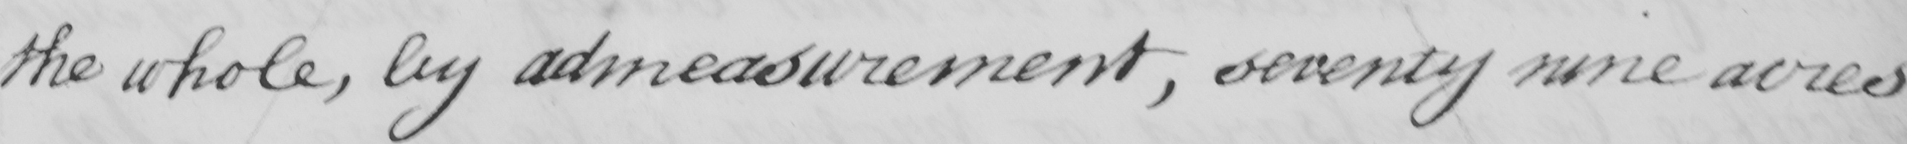Transcribe the text shown in this historical manuscript line. the whole , by admeasurement , seventy nine acres 